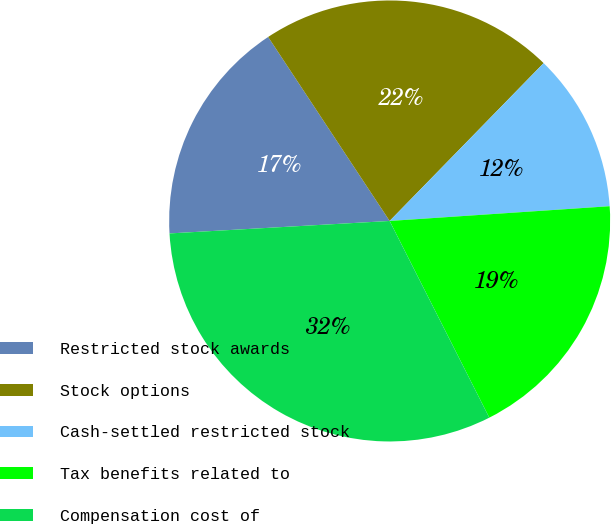Convert chart. <chart><loc_0><loc_0><loc_500><loc_500><pie_chart><fcel>Restricted stock awards<fcel>Stock options<fcel>Cash-settled restricted stock<fcel>Tax benefits related to<fcel>Compensation cost of<nl><fcel>16.61%<fcel>21.59%<fcel>11.63%<fcel>18.6%<fcel>31.56%<nl></chart> 